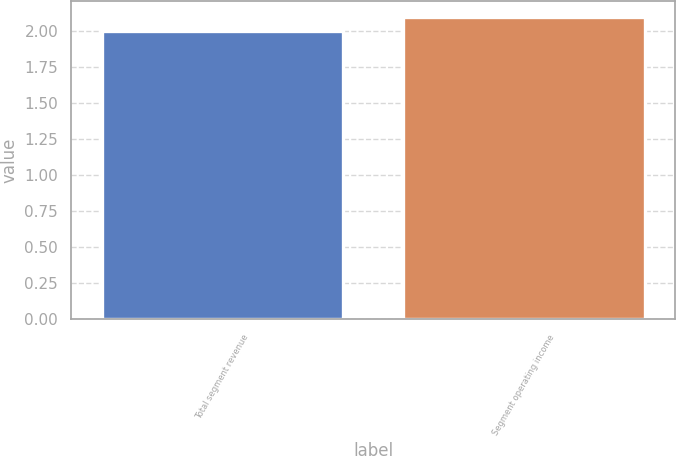Convert chart. <chart><loc_0><loc_0><loc_500><loc_500><bar_chart><fcel>Total segment revenue<fcel>Segment operating income<nl><fcel>2<fcel>2.1<nl></chart> 